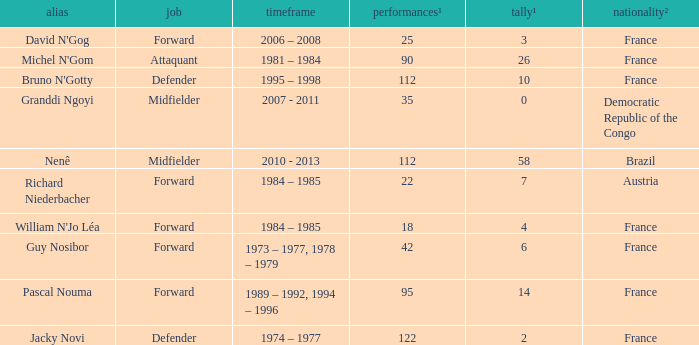How many games had less than 7 goals scored? 1.0. Would you mind parsing the complete table? {'header': ['alias', 'job', 'timeframe', 'performances¹', 'tally¹', 'nationality²'], 'rows': [["David N'Gog", 'Forward', '2006 – 2008', '25', '3', 'France'], ["Michel N'Gom", 'Attaquant', '1981 – 1984', '90', '26', 'France'], ["Bruno N'Gotty", 'Defender', '1995 – 1998', '112', '10', 'France'], ['Granddi Ngoyi', 'Midfielder', '2007 - 2011', '35', '0', 'Democratic Republic of the Congo'], ['Nenê', 'Midfielder', '2010 - 2013', '112', '58', 'Brazil'], ['Richard Niederbacher', 'Forward', '1984 – 1985', '22', '7', 'Austria'], ["William N'Jo Léa", 'Forward', '1984 – 1985', '18', '4', 'France'], ['Guy Nosibor', 'Forward', '1973 – 1977, 1978 – 1979', '42', '6', 'France'], ['Pascal Nouma', 'Forward', '1989 – 1992, 1994 – 1996', '95', '14', 'France'], ['Jacky Novi', 'Defender', '1974 – 1977', '122', '2', 'France']]} 